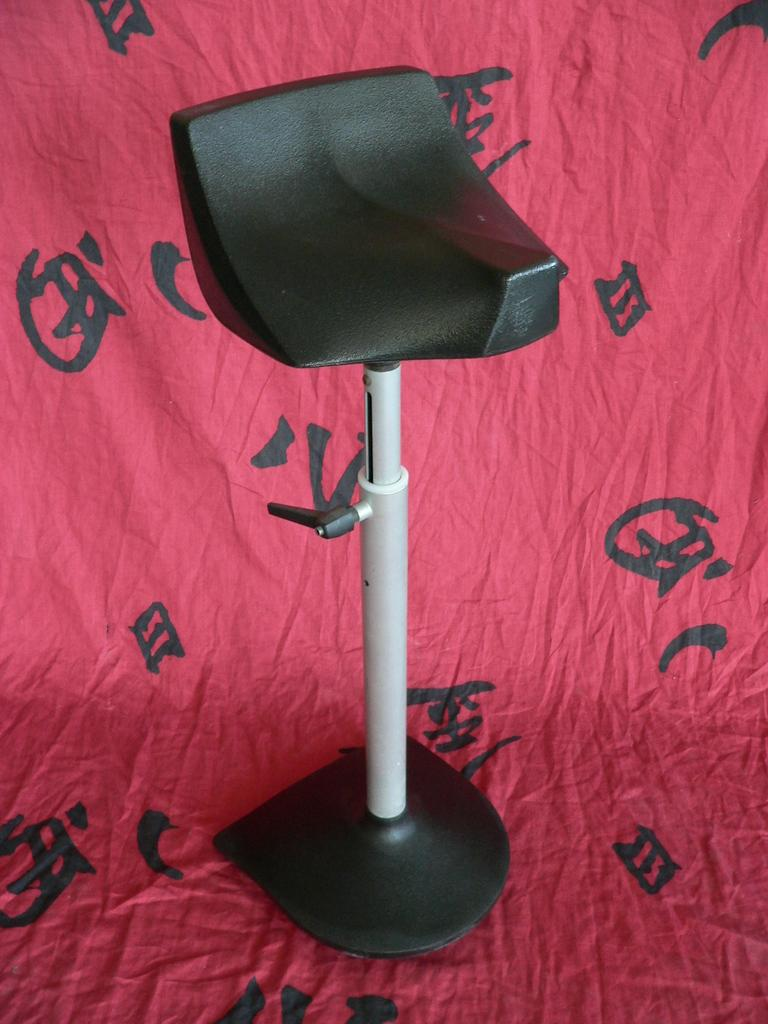What type of furniture is present in the image? There is a chair in the image. What color is the cloth that is visible in the image? The cloth is red. What language is written on the red cloth? The red cloth has Chinese script on it. Where is the family sitting on the stage in the image? There is no stage, family, or frog present in the image. The image only contains a chair and a red cloth with Chinese script on it. 